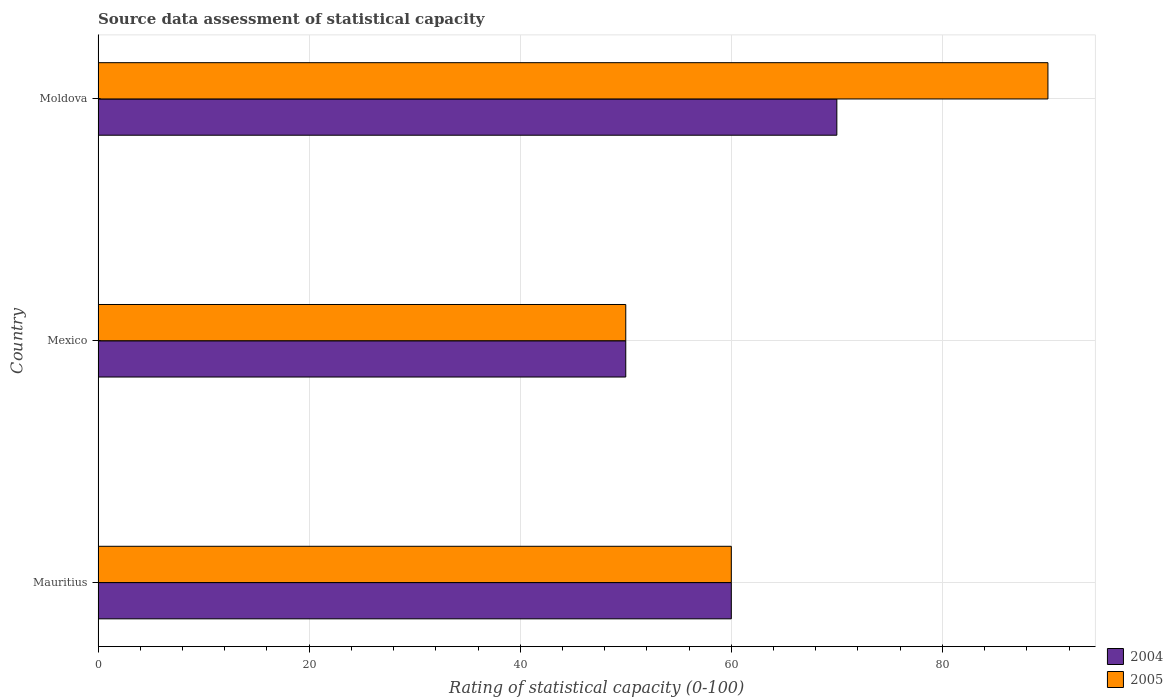How many groups of bars are there?
Offer a terse response. 3. How many bars are there on the 2nd tick from the top?
Your answer should be very brief. 2. How many bars are there on the 3rd tick from the bottom?
Your answer should be very brief. 2. What is the label of the 1st group of bars from the top?
Keep it short and to the point. Moldova. In which country was the rating of statistical capacity in 2004 maximum?
Make the answer very short. Moldova. What is the total rating of statistical capacity in 2004 in the graph?
Your answer should be very brief. 180. What is the difference between the rating of statistical capacity in 2005 in Mexico and that in Moldova?
Provide a succinct answer. -40. What is the difference between the rating of statistical capacity in 2005 in Mexico and the rating of statistical capacity in 2004 in Moldova?
Your answer should be compact. -20. What is the average rating of statistical capacity in 2004 per country?
Your answer should be very brief. 60. What is the difference between the rating of statistical capacity in 2005 and rating of statistical capacity in 2004 in Mexico?
Provide a short and direct response. 0. What is the ratio of the rating of statistical capacity in 2005 in Mexico to that in Moldova?
Ensure brevity in your answer.  0.56. Is the rating of statistical capacity in 2005 in Mexico less than that in Moldova?
Provide a short and direct response. Yes. Is the difference between the rating of statistical capacity in 2005 in Mauritius and Mexico greater than the difference between the rating of statistical capacity in 2004 in Mauritius and Mexico?
Your answer should be compact. No. What is the difference between the highest and the second highest rating of statistical capacity in 2004?
Offer a terse response. 10. What does the 2nd bar from the top in Mauritius represents?
Provide a succinct answer. 2004. Are all the bars in the graph horizontal?
Keep it short and to the point. Yes. What is the difference between two consecutive major ticks on the X-axis?
Offer a terse response. 20. Does the graph contain grids?
Make the answer very short. Yes. How many legend labels are there?
Offer a very short reply. 2. How are the legend labels stacked?
Offer a terse response. Vertical. What is the title of the graph?
Provide a short and direct response. Source data assessment of statistical capacity. Does "1961" appear as one of the legend labels in the graph?
Your answer should be very brief. No. What is the label or title of the X-axis?
Provide a short and direct response. Rating of statistical capacity (0-100). What is the label or title of the Y-axis?
Your answer should be very brief. Country. What is the Rating of statistical capacity (0-100) of 2004 in Mauritius?
Your response must be concise. 60. What is the Rating of statistical capacity (0-100) in 2005 in Mauritius?
Keep it short and to the point. 60. What is the Rating of statistical capacity (0-100) of 2004 in Mexico?
Make the answer very short. 50. What is the Rating of statistical capacity (0-100) in 2005 in Mexico?
Your response must be concise. 50. What is the Rating of statistical capacity (0-100) in 2004 in Moldova?
Ensure brevity in your answer.  70. Across all countries, what is the maximum Rating of statistical capacity (0-100) of 2004?
Your response must be concise. 70. Across all countries, what is the maximum Rating of statistical capacity (0-100) of 2005?
Provide a short and direct response. 90. What is the total Rating of statistical capacity (0-100) in 2004 in the graph?
Keep it short and to the point. 180. What is the total Rating of statistical capacity (0-100) of 2005 in the graph?
Offer a very short reply. 200. What is the difference between the Rating of statistical capacity (0-100) of 2004 in Mauritius and that in Mexico?
Offer a very short reply. 10. What is the difference between the Rating of statistical capacity (0-100) in 2004 in Mauritius and that in Moldova?
Your answer should be very brief. -10. What is the difference between the Rating of statistical capacity (0-100) of 2005 in Mexico and that in Moldova?
Ensure brevity in your answer.  -40. What is the difference between the Rating of statistical capacity (0-100) of 2004 in Mauritius and the Rating of statistical capacity (0-100) of 2005 in Mexico?
Provide a succinct answer. 10. What is the average Rating of statistical capacity (0-100) of 2004 per country?
Provide a short and direct response. 60. What is the average Rating of statistical capacity (0-100) of 2005 per country?
Your answer should be compact. 66.67. What is the difference between the Rating of statistical capacity (0-100) of 2004 and Rating of statistical capacity (0-100) of 2005 in Mauritius?
Provide a short and direct response. 0. What is the difference between the Rating of statistical capacity (0-100) in 2004 and Rating of statistical capacity (0-100) in 2005 in Moldova?
Ensure brevity in your answer.  -20. What is the ratio of the Rating of statistical capacity (0-100) of 2005 in Mauritius to that in Moldova?
Ensure brevity in your answer.  0.67. What is the ratio of the Rating of statistical capacity (0-100) in 2005 in Mexico to that in Moldova?
Make the answer very short. 0.56. What is the difference between the highest and the second highest Rating of statistical capacity (0-100) of 2004?
Provide a succinct answer. 10. What is the difference between the highest and the second highest Rating of statistical capacity (0-100) in 2005?
Give a very brief answer. 30. What is the difference between the highest and the lowest Rating of statistical capacity (0-100) in 2005?
Keep it short and to the point. 40. 